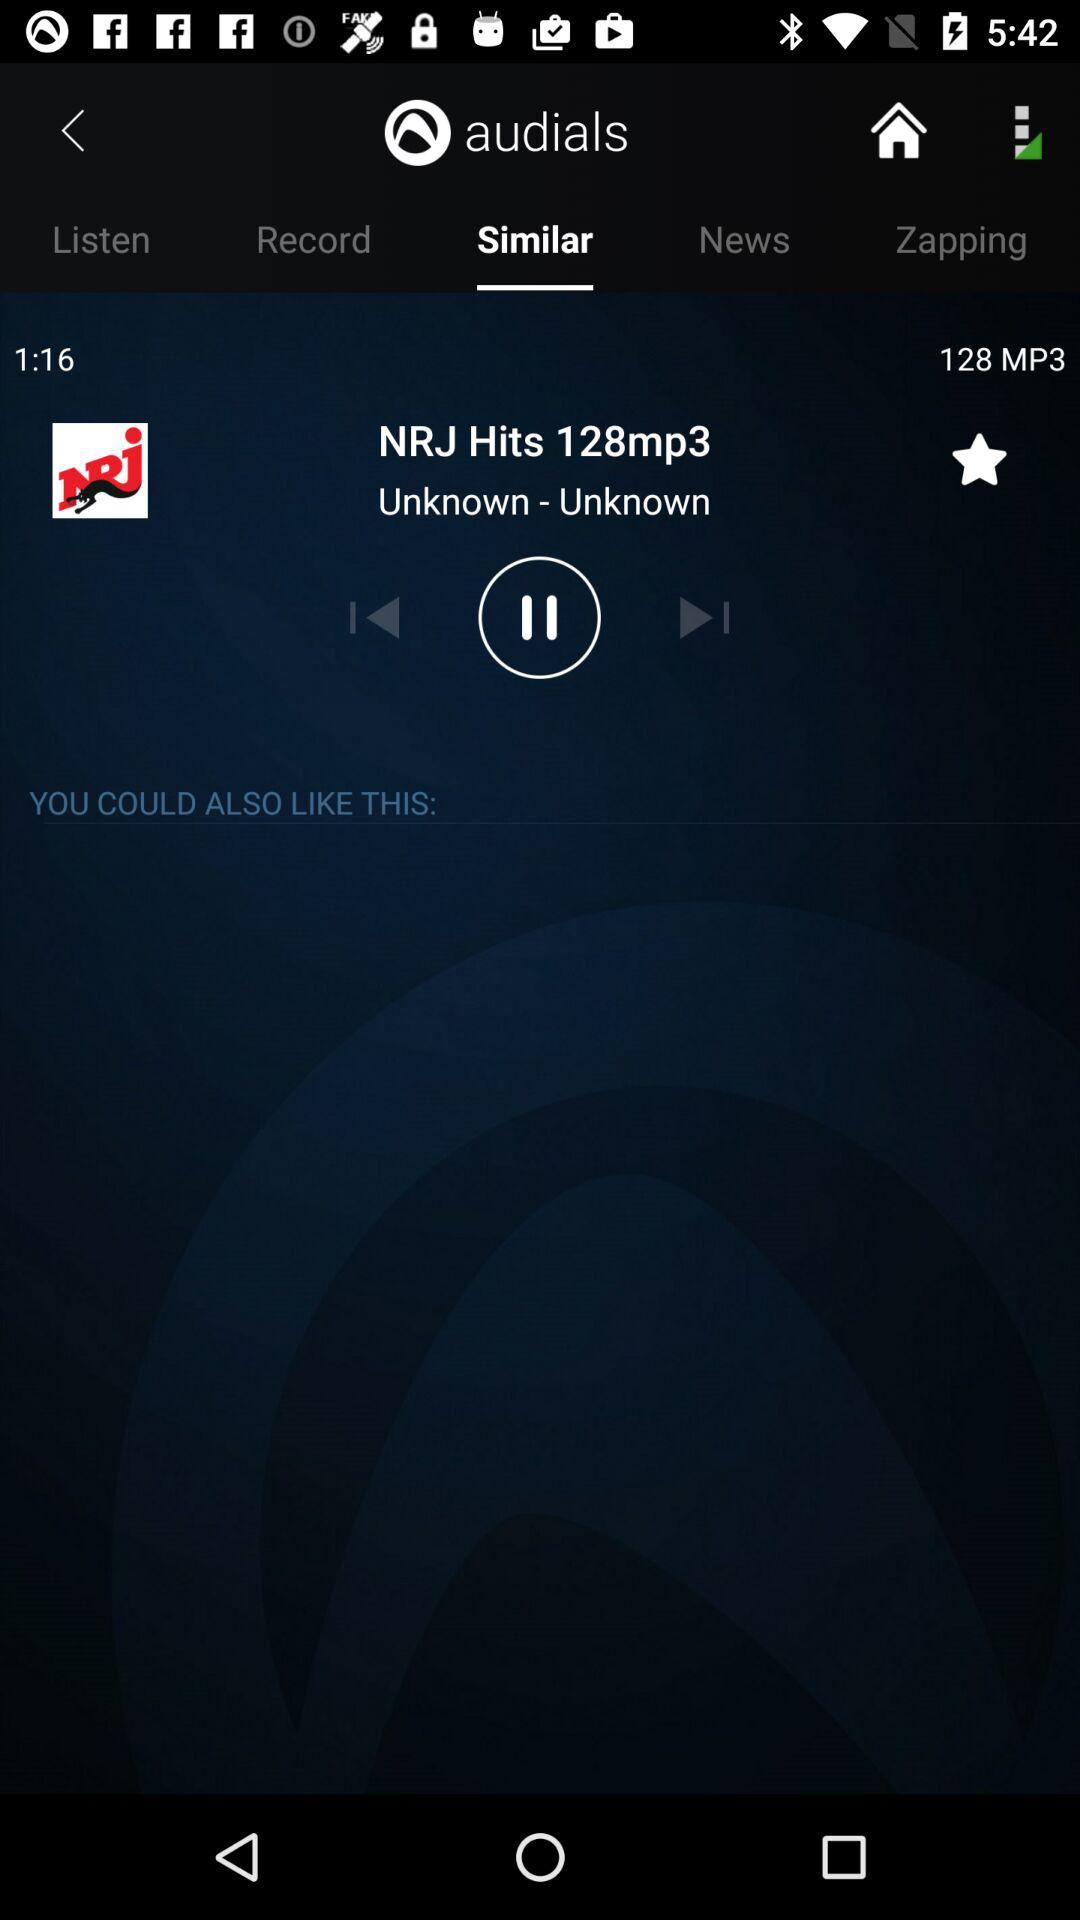What is the application name? The application name is "audials". 